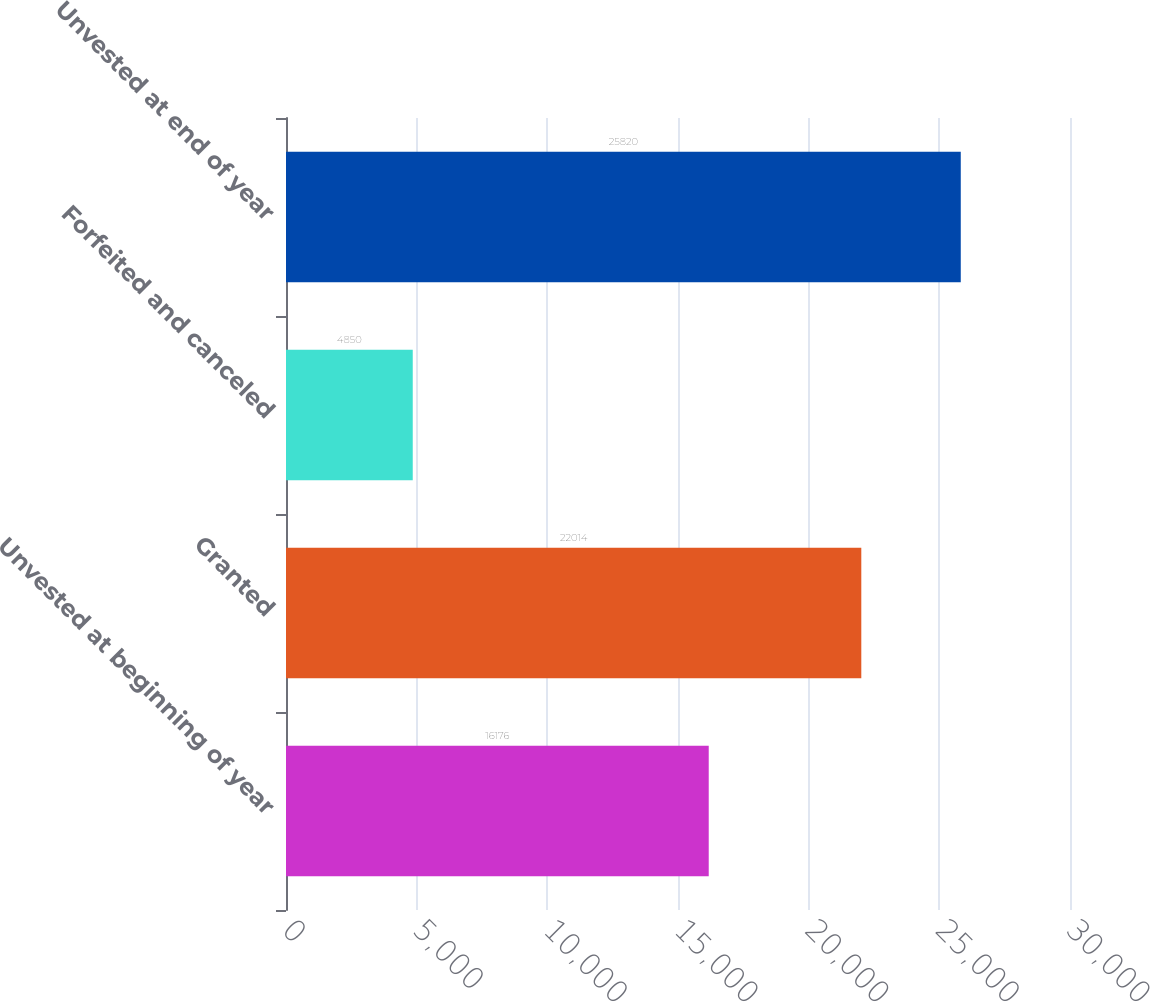Convert chart. <chart><loc_0><loc_0><loc_500><loc_500><bar_chart><fcel>Unvested at beginning of year<fcel>Granted<fcel>Forfeited and canceled<fcel>Unvested at end of year<nl><fcel>16176<fcel>22014<fcel>4850<fcel>25820<nl></chart> 